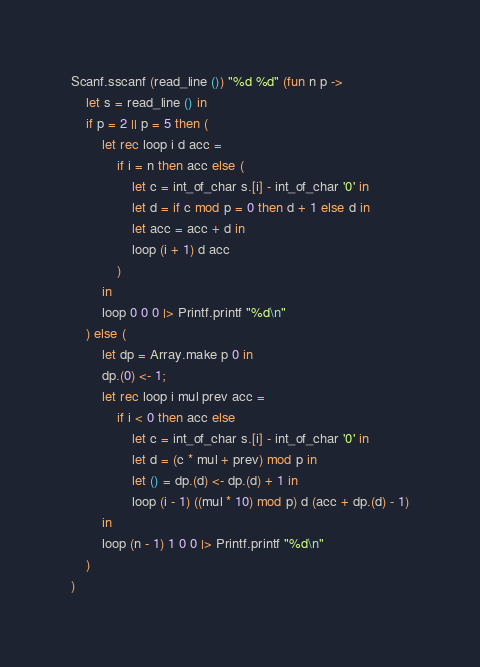<code> <loc_0><loc_0><loc_500><loc_500><_OCaml_>Scanf.sscanf (read_line ()) "%d %d" (fun n p ->
    let s = read_line () in
    if p = 2 || p = 5 then (
        let rec loop i d acc =
            if i = n then acc else (
                let c = int_of_char s.[i] - int_of_char '0' in
                let d = if c mod p = 0 then d + 1 else d in
                let acc = acc + d in
                loop (i + 1) d acc
            )
        in
        loop 0 0 0 |> Printf.printf "%d\n"
    ) else (
        let dp = Array.make p 0 in
        dp.(0) <- 1;
        let rec loop i mul prev acc =
            if i < 0 then acc else
                let c = int_of_char s.[i] - int_of_char '0' in
                let d = (c * mul + prev) mod p in
                let () = dp.(d) <- dp.(d) + 1 in
                loop (i - 1) ((mul * 10) mod p) d (acc + dp.(d) - 1)
        in
        loop (n - 1) 1 0 0 |> Printf.printf "%d\n" 
    )
)</code> 